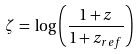<formula> <loc_0><loc_0><loc_500><loc_500>\zeta \, = \, \log \left ( \frac { 1 + z } { 1 + z _ { r e f } } \right )</formula> 